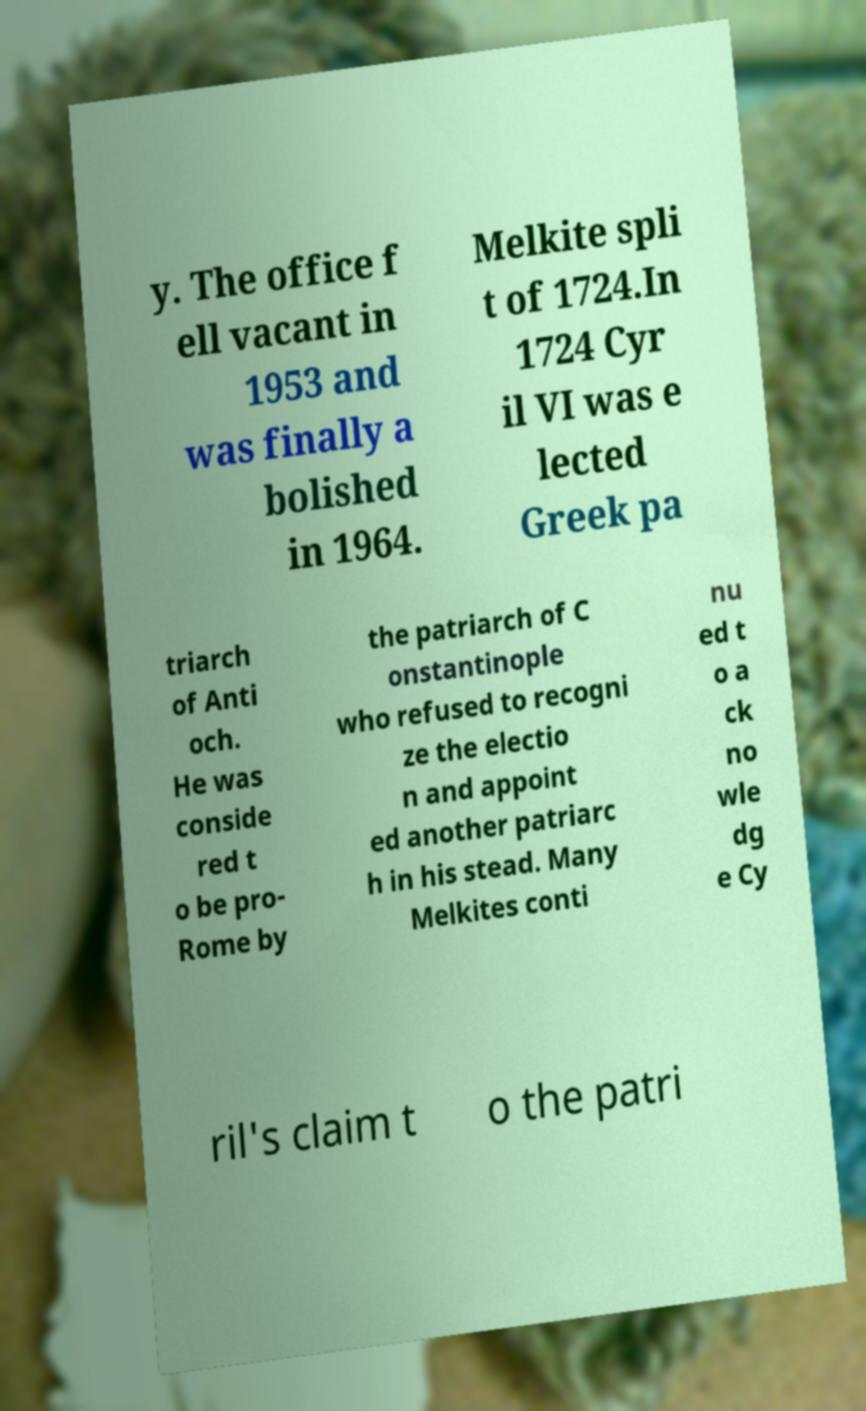For documentation purposes, I need the text within this image transcribed. Could you provide that? y. The office f ell vacant in 1953 and was finally a bolished in 1964. Melkite spli t of 1724.In 1724 Cyr il VI was e lected Greek pa triarch of Anti och. He was conside red t o be pro- Rome by the patriarch of C onstantinople who refused to recogni ze the electio n and appoint ed another patriarc h in his stead. Many Melkites conti nu ed t o a ck no wle dg e Cy ril's claim t o the patri 